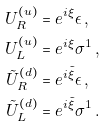<formula> <loc_0><loc_0><loc_500><loc_500>U _ { R } ^ { ( u ) } & = e ^ { i \xi } \epsilon \, , \\ U _ { L } ^ { ( u ) } & = e ^ { i \xi } \sigma ^ { 1 } \, , \\ \tilde { U } _ { R } ^ { ( d ) } & = e ^ { i \tilde { \xi } } \epsilon \, , \\ \tilde { U } _ { L } ^ { ( d ) } & = e ^ { i \tilde { \xi } } \sigma ^ { 1 } \, .</formula> 